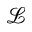Convert formula to latex. <formula><loc_0><loc_0><loc_500><loc_500>\mathcal { L }</formula> 